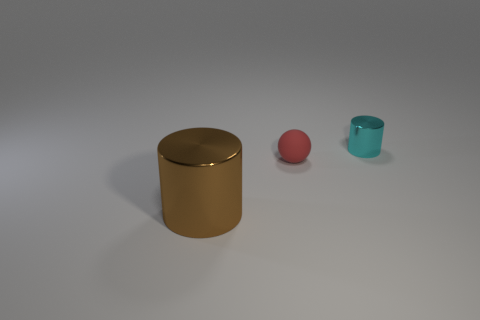Add 1 cyan objects. How many objects exist? 4 Subtract all cyan cylinders. How many cylinders are left? 1 Subtract 1 cylinders. How many cylinders are left? 1 Subtract all yellow spheres. How many cyan cylinders are left? 1 Subtract all spheres. How many objects are left? 2 Subtract 0 blue cylinders. How many objects are left? 3 Subtract all yellow cylinders. Subtract all purple cubes. How many cylinders are left? 2 Subtract all big blue cylinders. Subtract all metal cylinders. How many objects are left? 1 Add 1 tiny matte balls. How many tiny matte balls are left? 2 Add 3 red rubber cylinders. How many red rubber cylinders exist? 3 